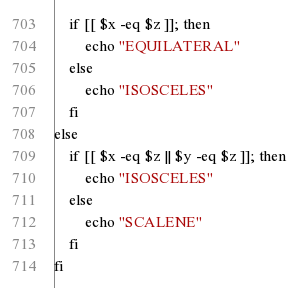Convert code to text. <code><loc_0><loc_0><loc_500><loc_500><_Bash_>	if [[ $x -eq $z ]]; then
		echo "EQUILATERAL"
	else
		echo "ISOSCELES"
	fi
else
	if [[ $x -eq $z || $y -eq $z ]]; then
		echo "ISOSCELES"
	else
		echo "SCALENE"
	fi
fi
</code> 